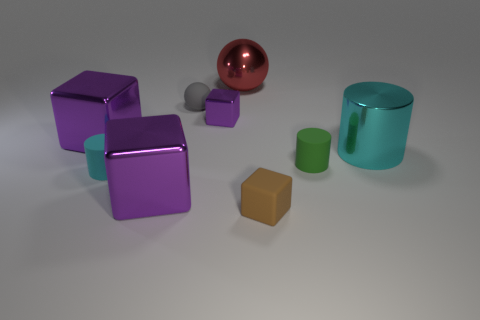How many purple blocks must be subtracted to get 1 purple blocks? 2 Subtract all yellow spheres. How many purple blocks are left? 3 Subtract 1 blocks. How many blocks are left? 3 Add 1 tiny rubber cylinders. How many objects exist? 10 Subtract all cylinders. How many objects are left? 6 Add 9 big matte things. How many big matte things exist? 9 Subtract 1 gray balls. How many objects are left? 8 Subtract all tiny cyan metallic cylinders. Subtract all small green rubber things. How many objects are left? 8 Add 6 purple things. How many purple things are left? 9 